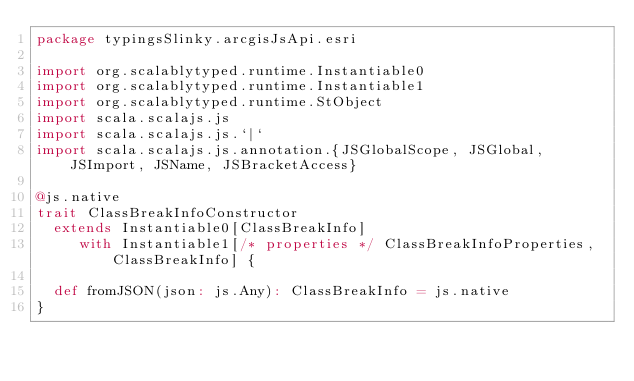<code> <loc_0><loc_0><loc_500><loc_500><_Scala_>package typingsSlinky.arcgisJsApi.esri

import org.scalablytyped.runtime.Instantiable0
import org.scalablytyped.runtime.Instantiable1
import org.scalablytyped.runtime.StObject
import scala.scalajs.js
import scala.scalajs.js.`|`
import scala.scalajs.js.annotation.{JSGlobalScope, JSGlobal, JSImport, JSName, JSBracketAccess}

@js.native
trait ClassBreakInfoConstructor
  extends Instantiable0[ClassBreakInfo]
     with Instantiable1[/* properties */ ClassBreakInfoProperties, ClassBreakInfo] {
  
  def fromJSON(json: js.Any): ClassBreakInfo = js.native
}
</code> 